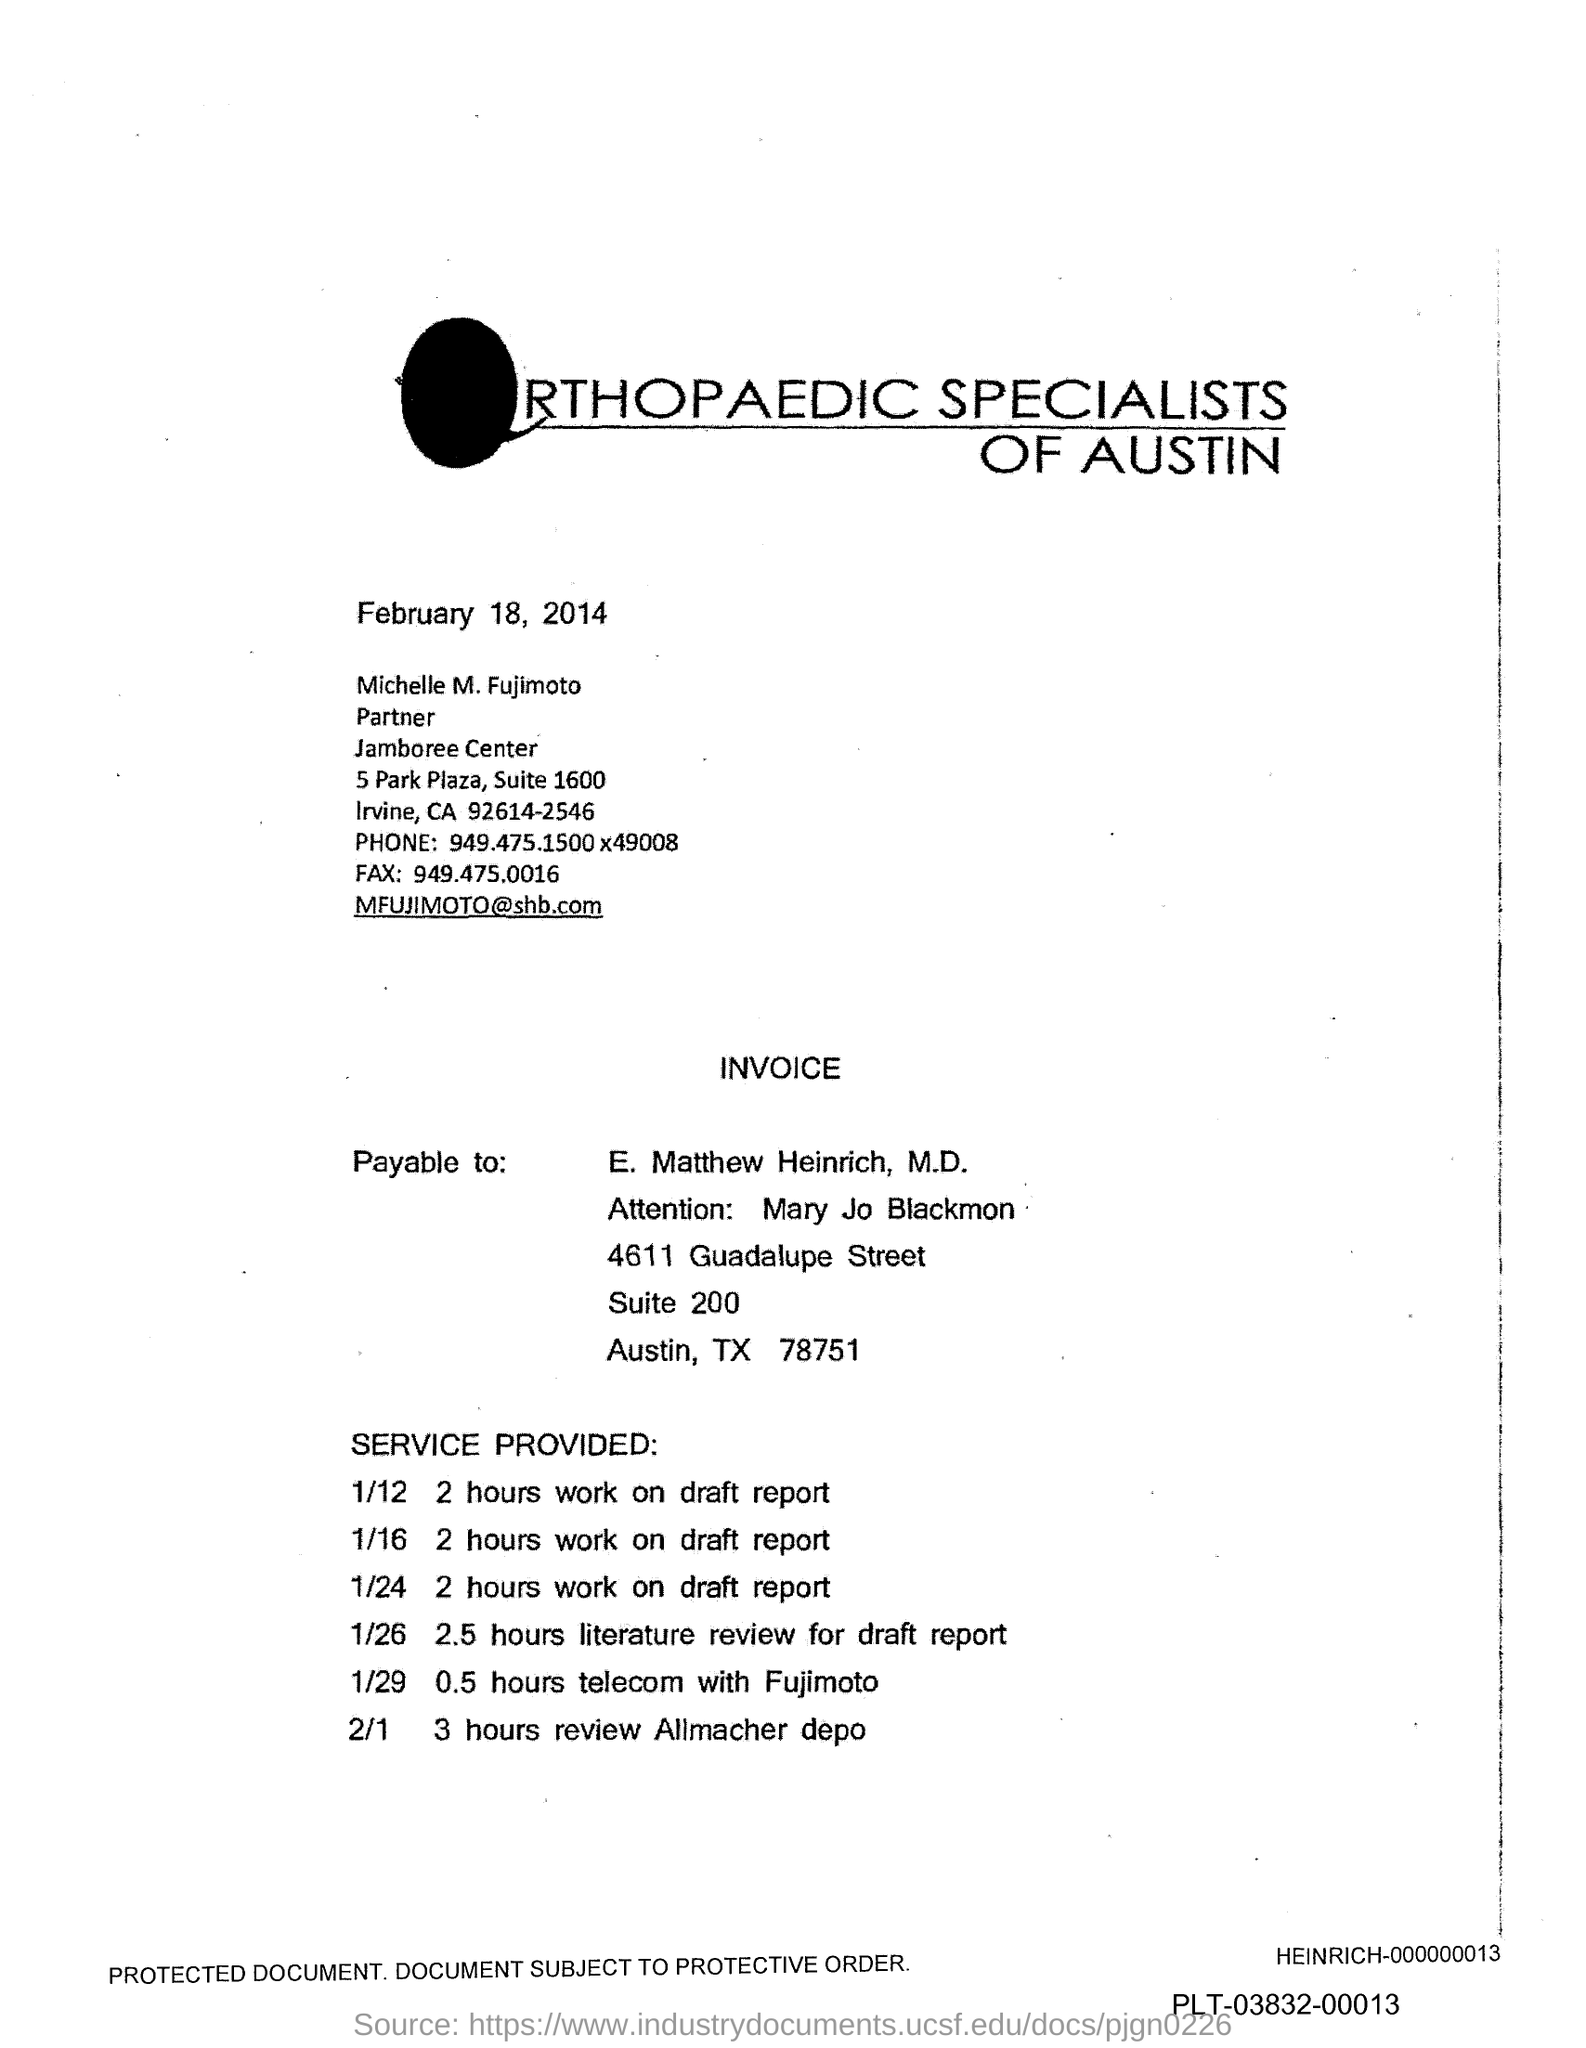Outline some significant characteristics in this image. The fax number is 949.475.0016. 